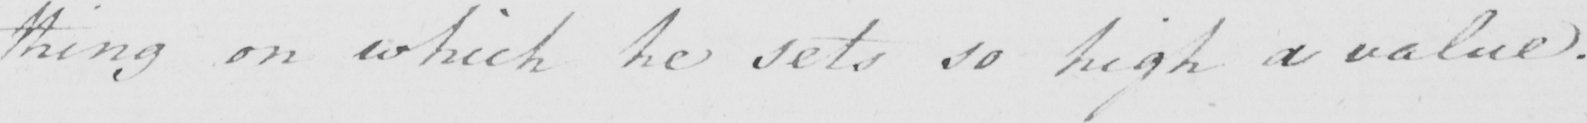What does this handwritten line say? thing on which he sets so high a value . 